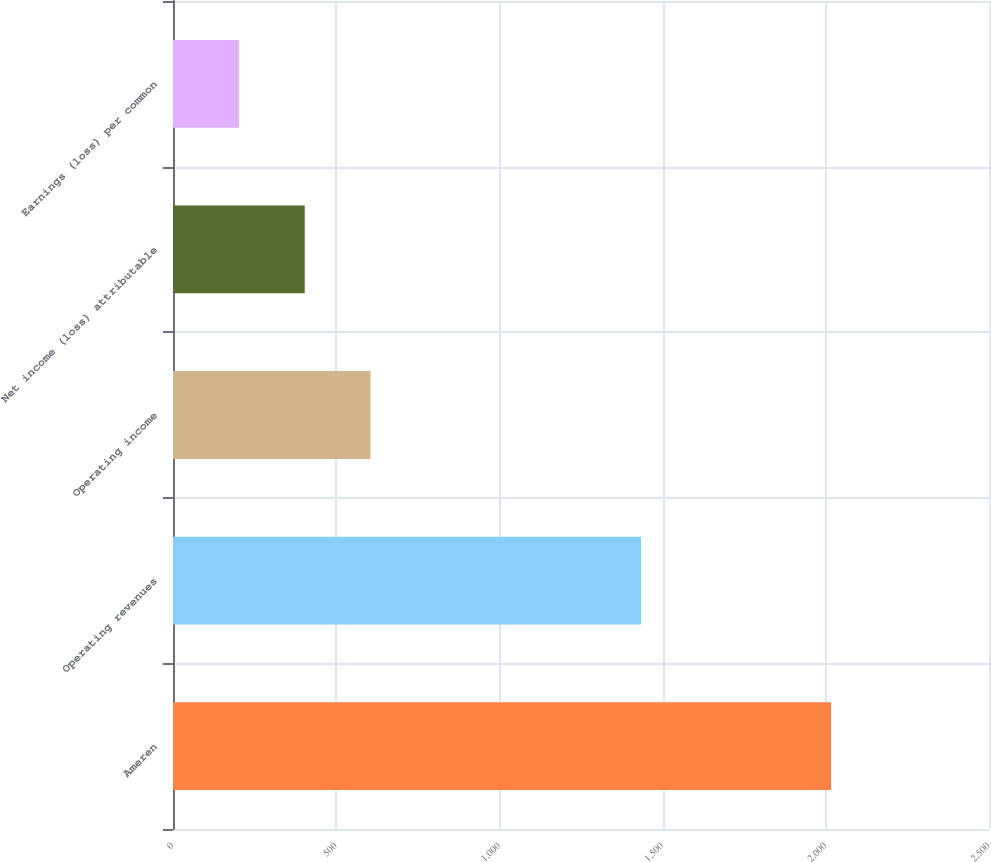Convert chart. <chart><loc_0><loc_0><loc_500><loc_500><bar_chart><fcel>Ameren<fcel>Operating revenues<fcel>Operating income<fcel>Net income (loss) attributable<fcel>Earnings (loss) per common<nl><fcel>2016<fcel>1434<fcel>605.11<fcel>403.55<fcel>201.99<nl></chart> 